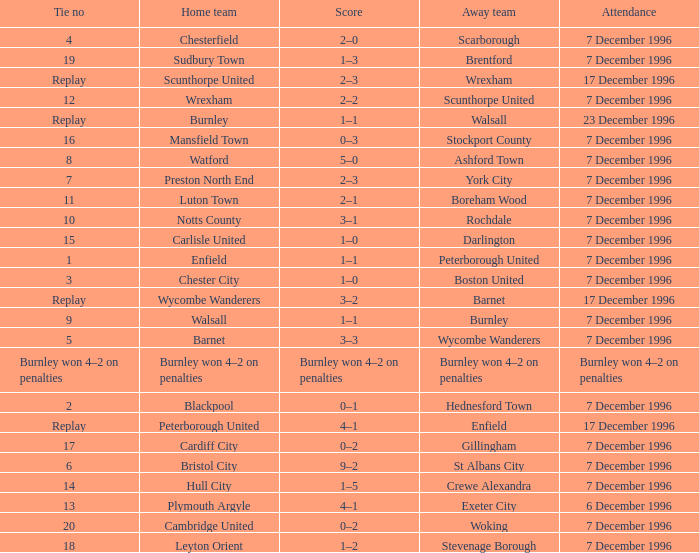Parse the full table. {'header': ['Tie no', 'Home team', 'Score', 'Away team', 'Attendance'], 'rows': [['4', 'Chesterfield', '2–0', 'Scarborough', '7 December 1996'], ['19', 'Sudbury Town', '1–3', 'Brentford', '7 December 1996'], ['Replay', 'Scunthorpe United', '2–3', 'Wrexham', '17 December 1996'], ['12', 'Wrexham', '2–2', 'Scunthorpe United', '7 December 1996'], ['Replay', 'Burnley', '1–1', 'Walsall', '23 December 1996'], ['16', 'Mansfield Town', '0–3', 'Stockport County', '7 December 1996'], ['8', 'Watford', '5–0', 'Ashford Town', '7 December 1996'], ['7', 'Preston North End', '2–3', 'York City', '7 December 1996'], ['11', 'Luton Town', '2–1', 'Boreham Wood', '7 December 1996'], ['10', 'Notts County', '3–1', 'Rochdale', '7 December 1996'], ['15', 'Carlisle United', '1–0', 'Darlington', '7 December 1996'], ['1', 'Enfield', '1–1', 'Peterborough United', '7 December 1996'], ['3', 'Chester City', '1–0', 'Boston United', '7 December 1996'], ['Replay', 'Wycombe Wanderers', '3–2', 'Barnet', '17 December 1996'], ['9', 'Walsall', '1–1', 'Burnley', '7 December 1996'], ['5', 'Barnet', '3–3', 'Wycombe Wanderers', '7 December 1996'], ['Burnley won 4–2 on penalties', 'Burnley won 4–2 on penalties', 'Burnley won 4–2 on penalties', 'Burnley won 4–2 on penalties', 'Burnley won 4–2 on penalties'], ['2', 'Blackpool', '0–1', 'Hednesford Town', '7 December 1996'], ['Replay', 'Peterborough United', '4–1', 'Enfield', '17 December 1996'], ['17', 'Cardiff City', '0–2', 'Gillingham', '7 December 1996'], ['6', 'Bristol City', '9–2', 'St Albans City', '7 December 1996'], ['14', 'Hull City', '1–5', 'Crewe Alexandra', '7 December 1996'], ['13', 'Plymouth Argyle', '4–1', 'Exeter City', '6 December 1996'], ['20', 'Cambridge United', '0–2', 'Woking', '7 December 1996'], ['18', 'Leyton Orient', '1–2', 'Stevenage Borough', '7 December 1996']]} Who were the away team in tie number 20? Woking. 